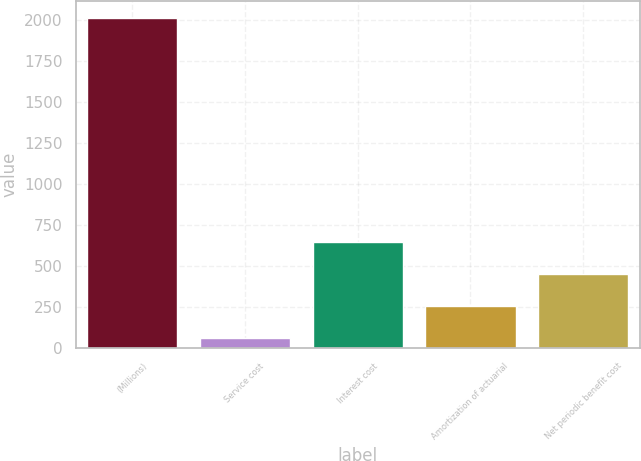Convert chart to OTSL. <chart><loc_0><loc_0><loc_500><loc_500><bar_chart><fcel>(Millions)<fcel>Service cost<fcel>Interest cost<fcel>Amortization of actuarial<fcel>Net periodic benefit cost<nl><fcel>2012<fcel>61<fcel>646.3<fcel>256.1<fcel>451.2<nl></chart> 